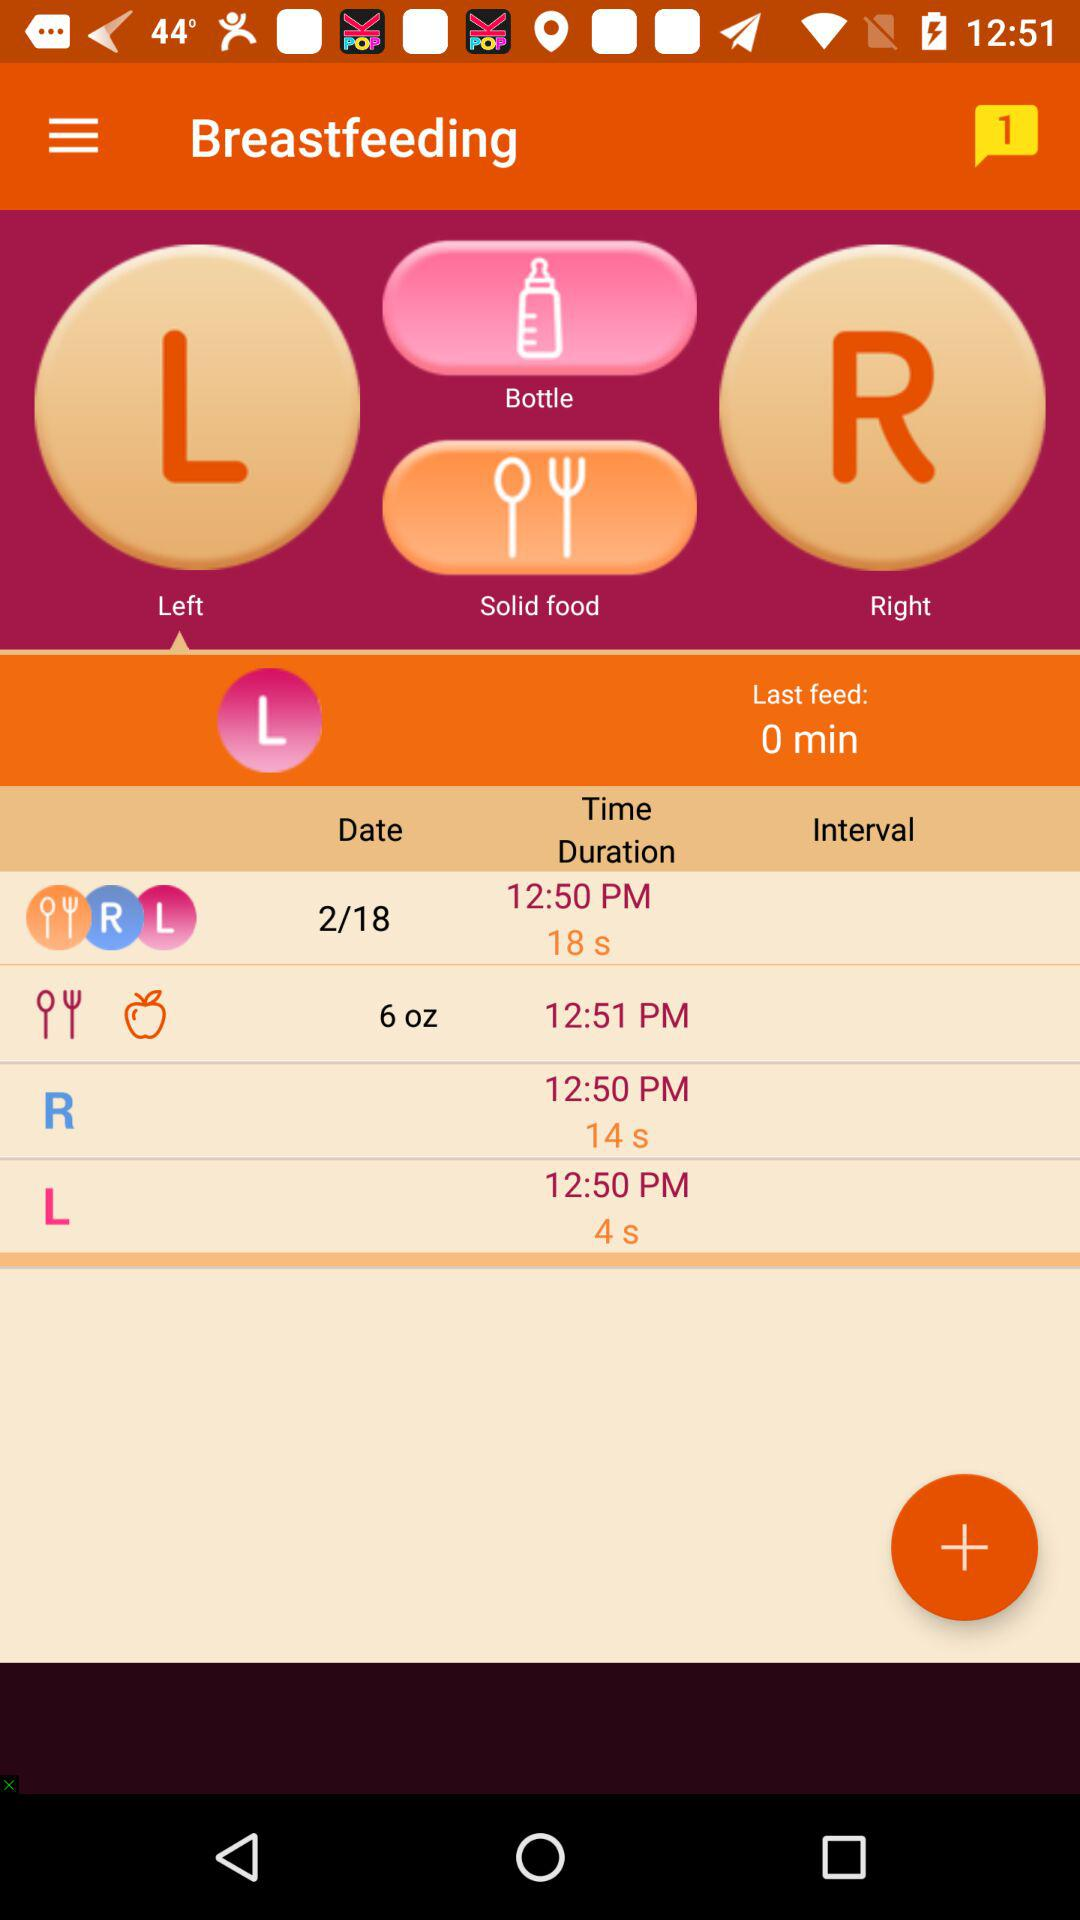When was the last feed? The last feed was 0 minutes ago. 